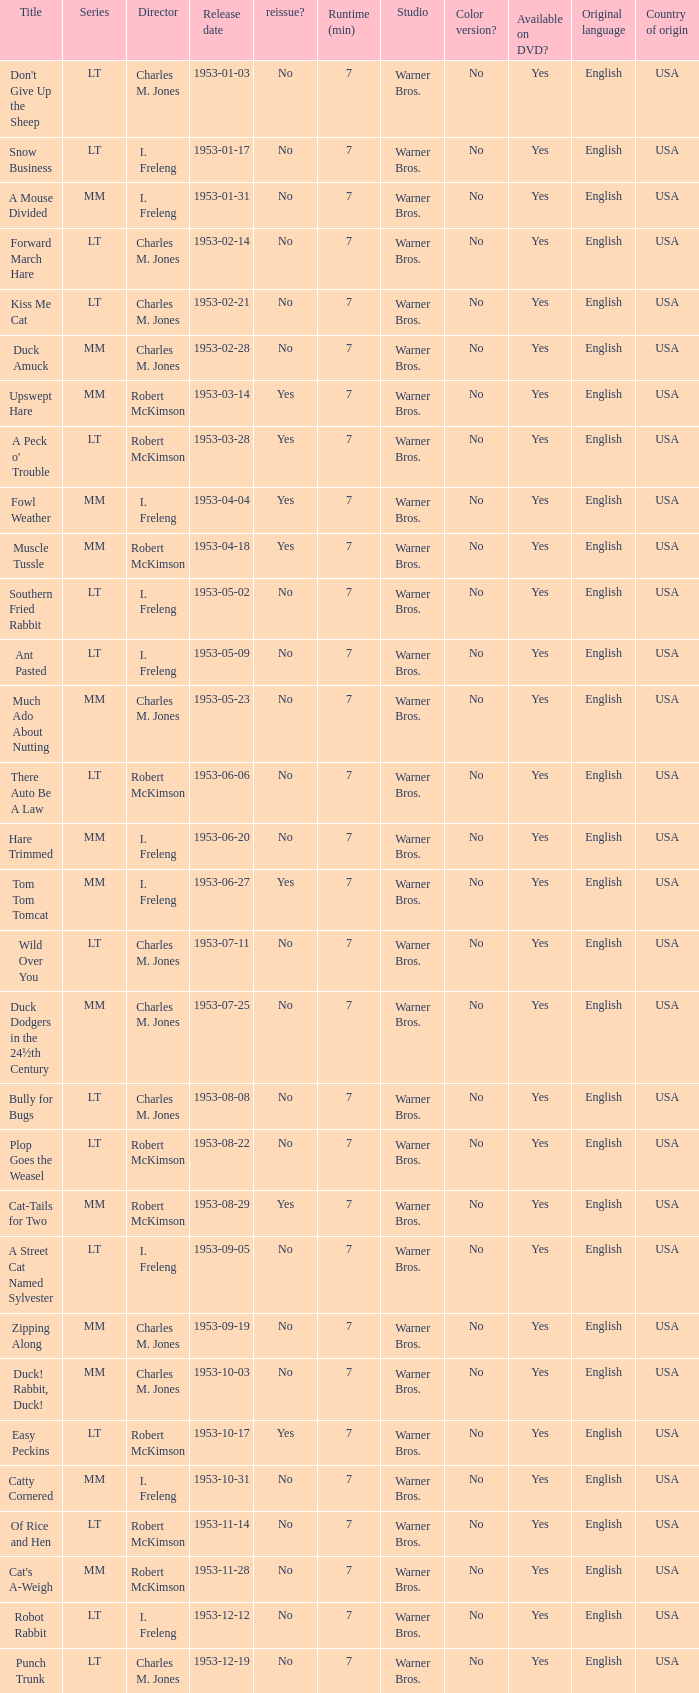Was there a reissue of the film released on 1953-10-03? No. 